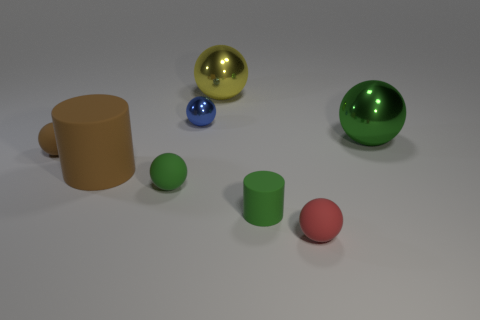Subtract 1 balls. How many balls are left? 5 Subtract all green balls. How many balls are left? 4 Subtract all small green spheres. How many spheres are left? 5 Subtract all purple spheres. Subtract all red cylinders. How many spheres are left? 6 Add 2 big rubber cylinders. How many objects exist? 10 Subtract all balls. How many objects are left? 2 Add 2 small blue balls. How many small blue balls exist? 3 Subtract 1 yellow spheres. How many objects are left? 7 Subtract all big spheres. Subtract all red balls. How many objects are left? 5 Add 4 matte cylinders. How many matte cylinders are left? 6 